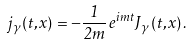Convert formula to latex. <formula><loc_0><loc_0><loc_500><loc_500>j _ { \gamma } ( t , { x } ) = - \frac { 1 } { 2 m } \, e ^ { i m t } J _ { \gamma } ( t , { x } ) \, .</formula> 